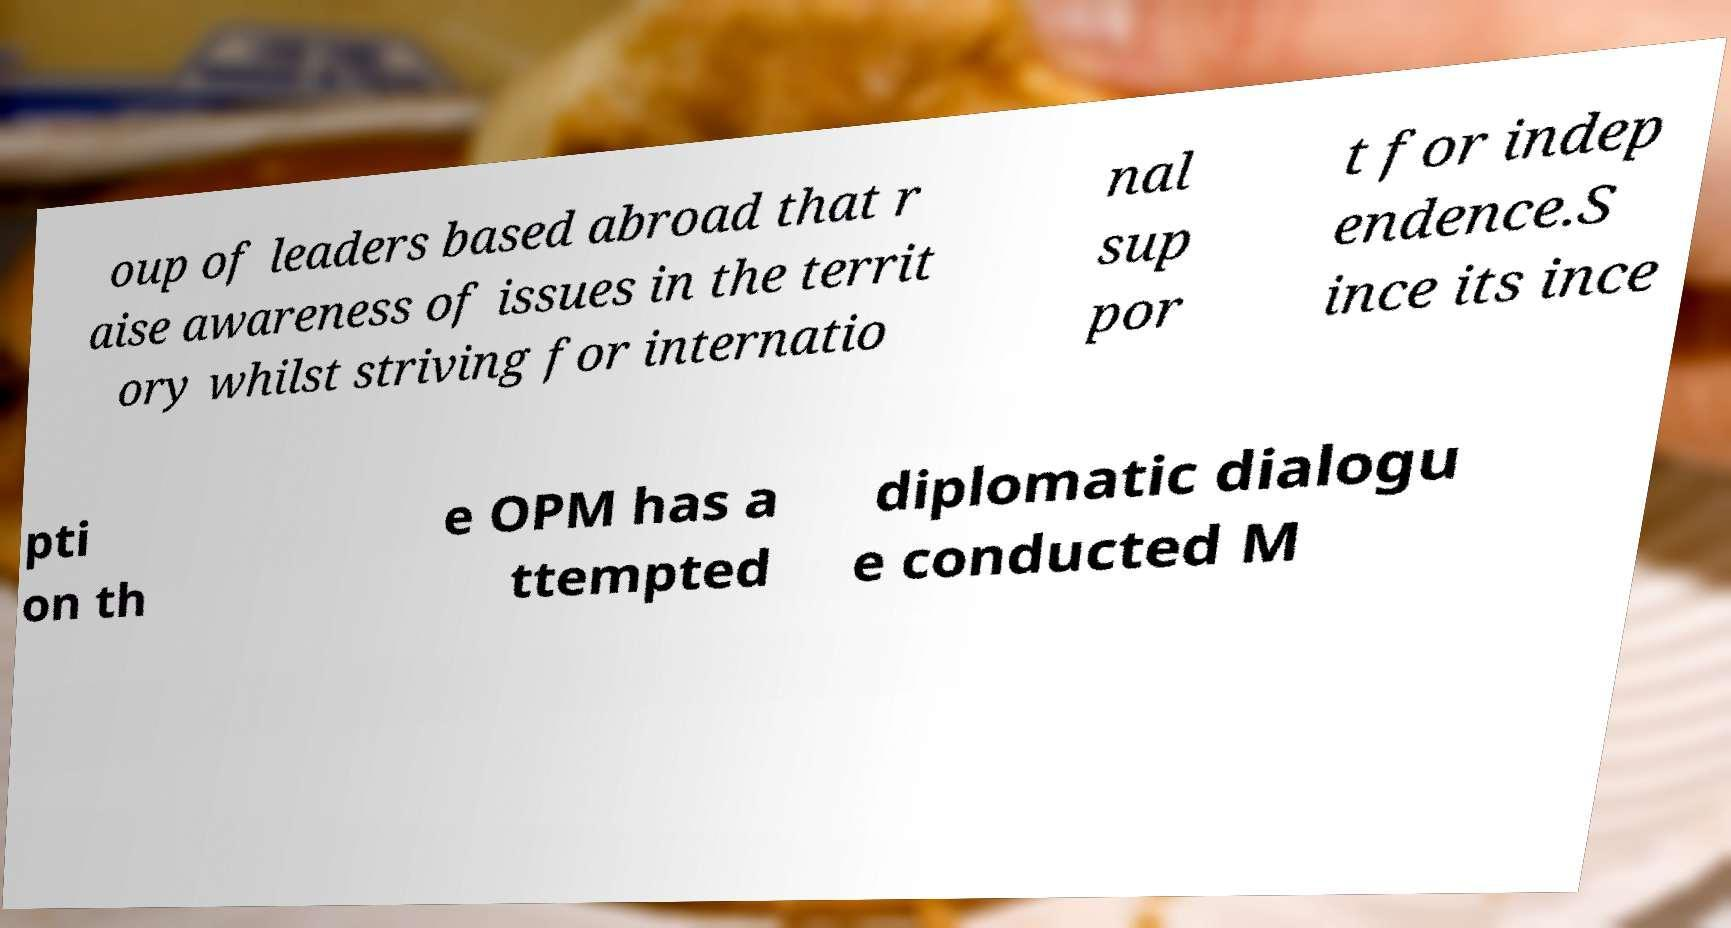Can you read and provide the text displayed in the image?This photo seems to have some interesting text. Can you extract and type it out for me? oup of leaders based abroad that r aise awareness of issues in the territ ory whilst striving for internatio nal sup por t for indep endence.S ince its ince pti on th e OPM has a ttempted diplomatic dialogu e conducted M 